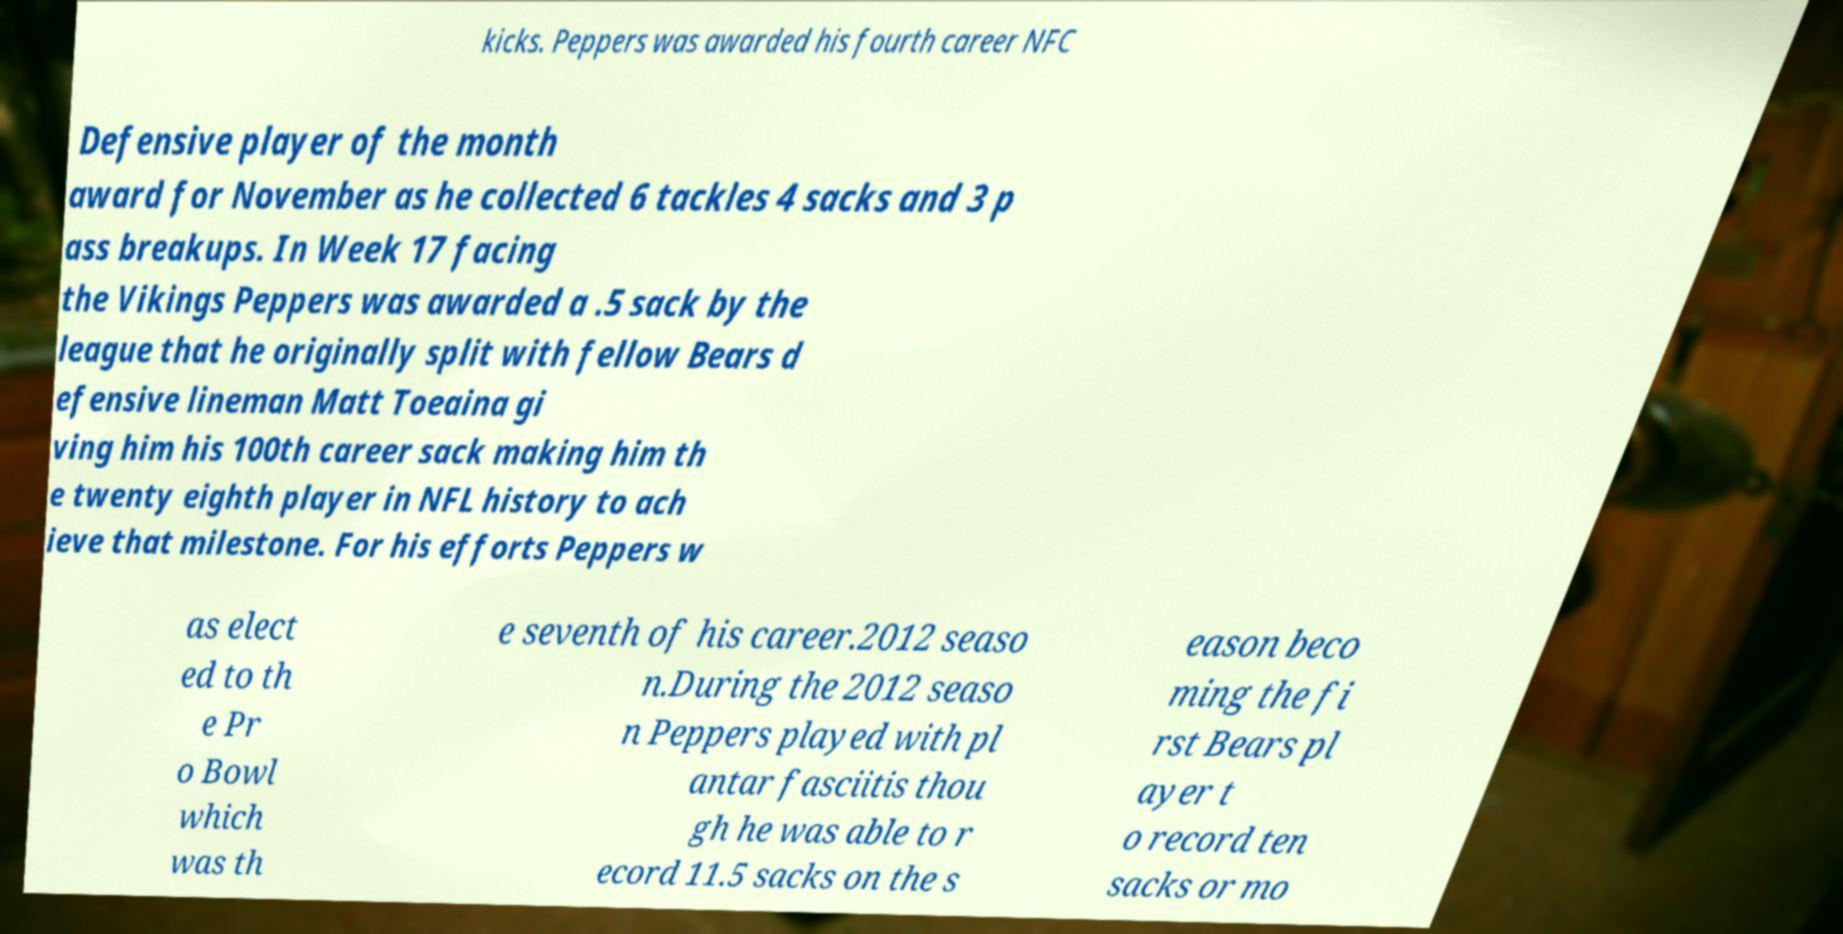Could you extract and type out the text from this image? kicks. Peppers was awarded his fourth career NFC Defensive player of the month award for November as he collected 6 tackles 4 sacks and 3 p ass breakups. In Week 17 facing the Vikings Peppers was awarded a .5 sack by the league that he originally split with fellow Bears d efensive lineman Matt Toeaina gi ving him his 100th career sack making him th e twenty eighth player in NFL history to ach ieve that milestone. For his efforts Peppers w as elect ed to th e Pr o Bowl which was th e seventh of his career.2012 seaso n.During the 2012 seaso n Peppers played with pl antar fasciitis thou gh he was able to r ecord 11.5 sacks on the s eason beco ming the fi rst Bears pl ayer t o record ten sacks or mo 